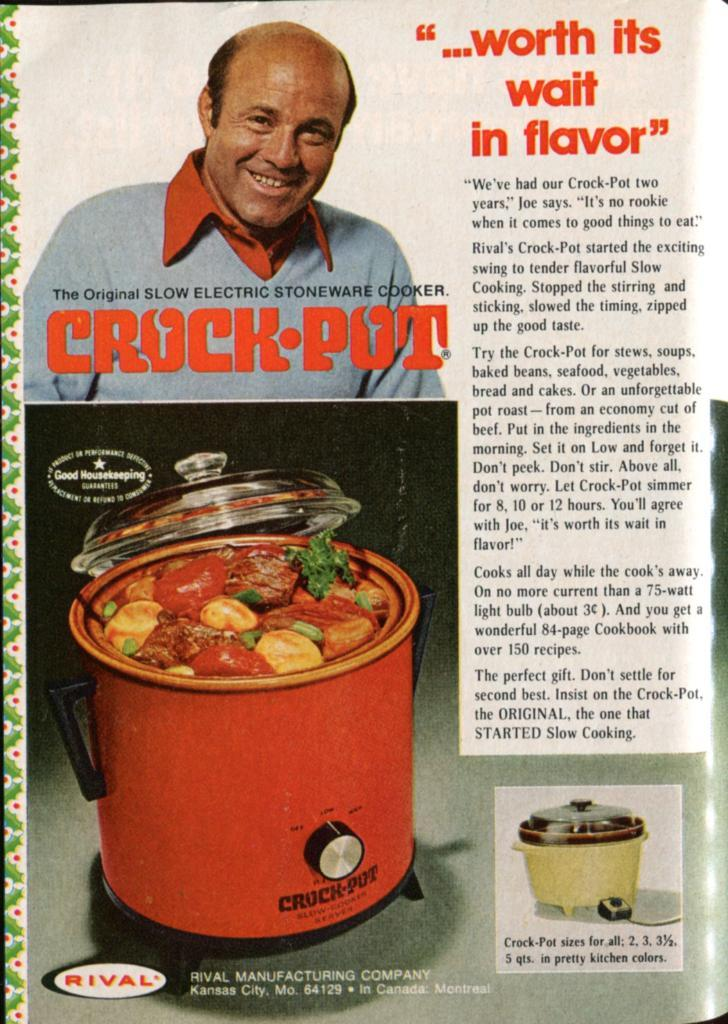<image>
Create a compact narrative representing the image presented. Page from a magazine that says "Crockpot" and shows a man's face. 